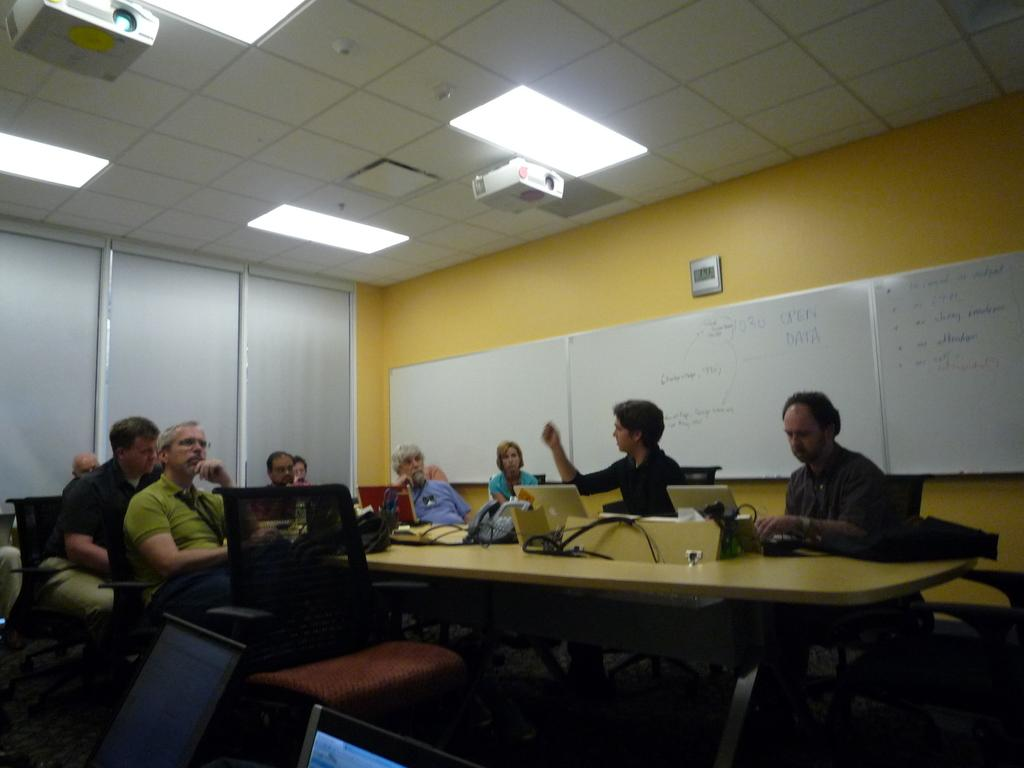What are the people in the image doing? The people in the image are sitting on chairs and operating laptops. What can be seen on the right side of the image? There are whiteboards on the right side of the image. What device is visible at the top of the image? There is a projector at the top of the image. What type of lighting is present in the image? There are lights visible in the image. Where is the rifle located in the image? There is no rifle present in the image. What is the end result of the people's activities in the image? The image does not show the end result of the people's activities; it only shows them operating laptops and sitting on chairs. 